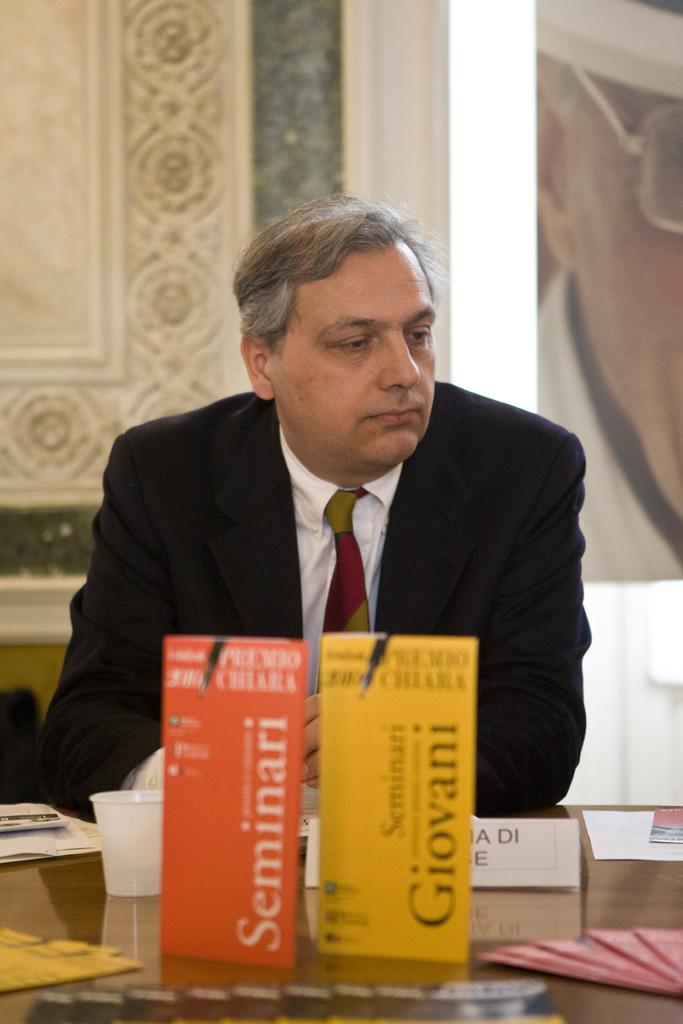<image>
Describe the image concisely. Seminari and Seminari Giovani booklets sitting on a brown table. 